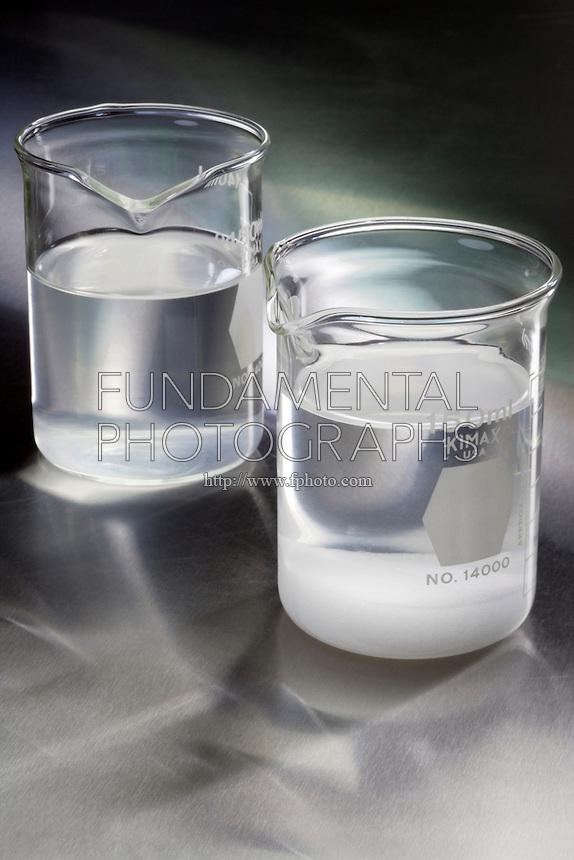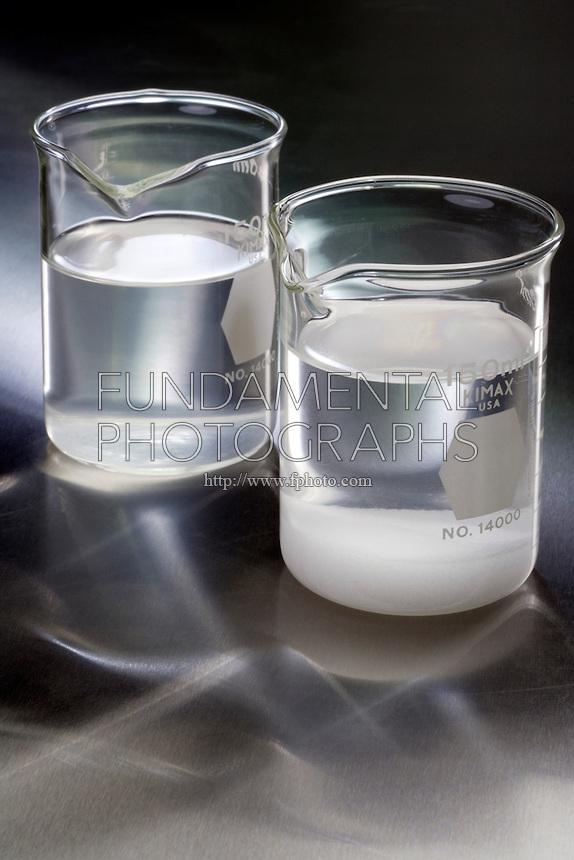The first image is the image on the left, the second image is the image on the right. Assess this claim about the two images: "There are four measuring glasses.". Correct or not? Answer yes or no. Yes. The first image is the image on the left, the second image is the image on the right. Given the left and right images, does the statement "There are four beakers in total." hold true? Answer yes or no. Yes. 